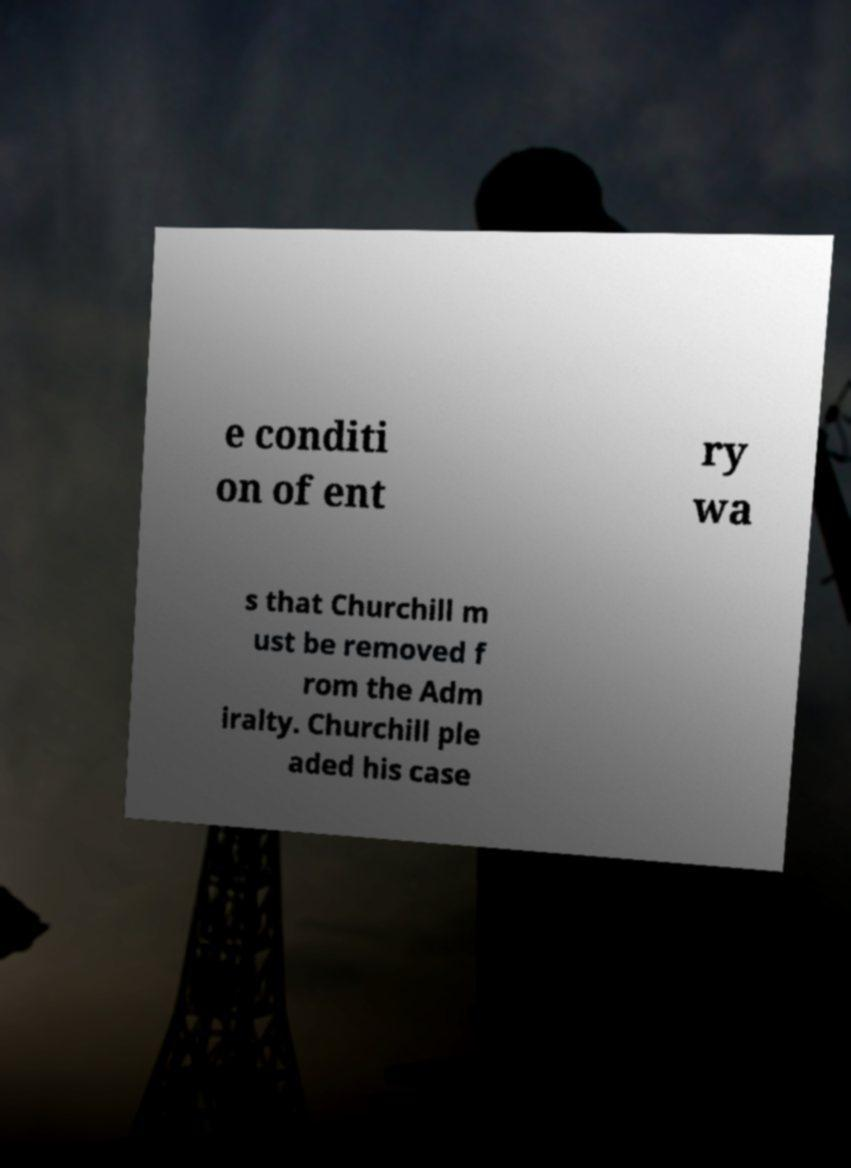Please identify and transcribe the text found in this image. e conditi on of ent ry wa s that Churchill m ust be removed f rom the Adm iralty. Churchill ple aded his case 